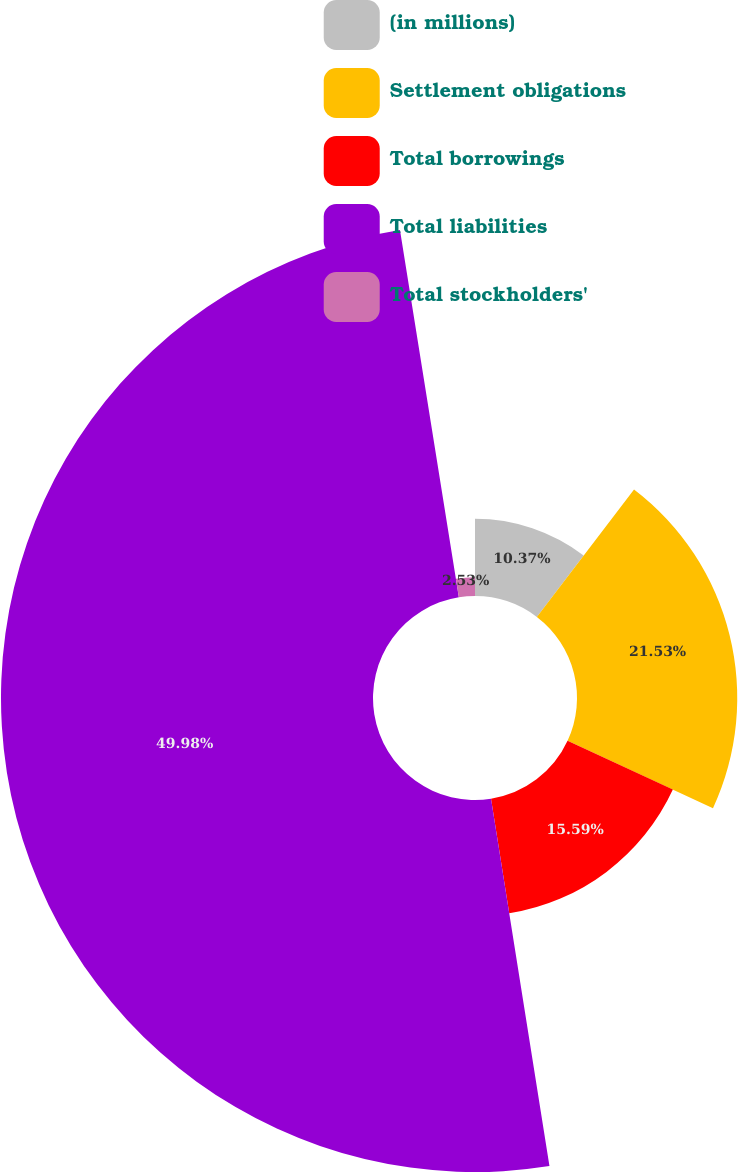<chart> <loc_0><loc_0><loc_500><loc_500><pie_chart><fcel>(in millions)<fcel>Settlement obligations<fcel>Total borrowings<fcel>Total liabilities<fcel>Total stockholders'<nl><fcel>10.37%<fcel>21.53%<fcel>15.59%<fcel>49.98%<fcel>2.53%<nl></chart> 